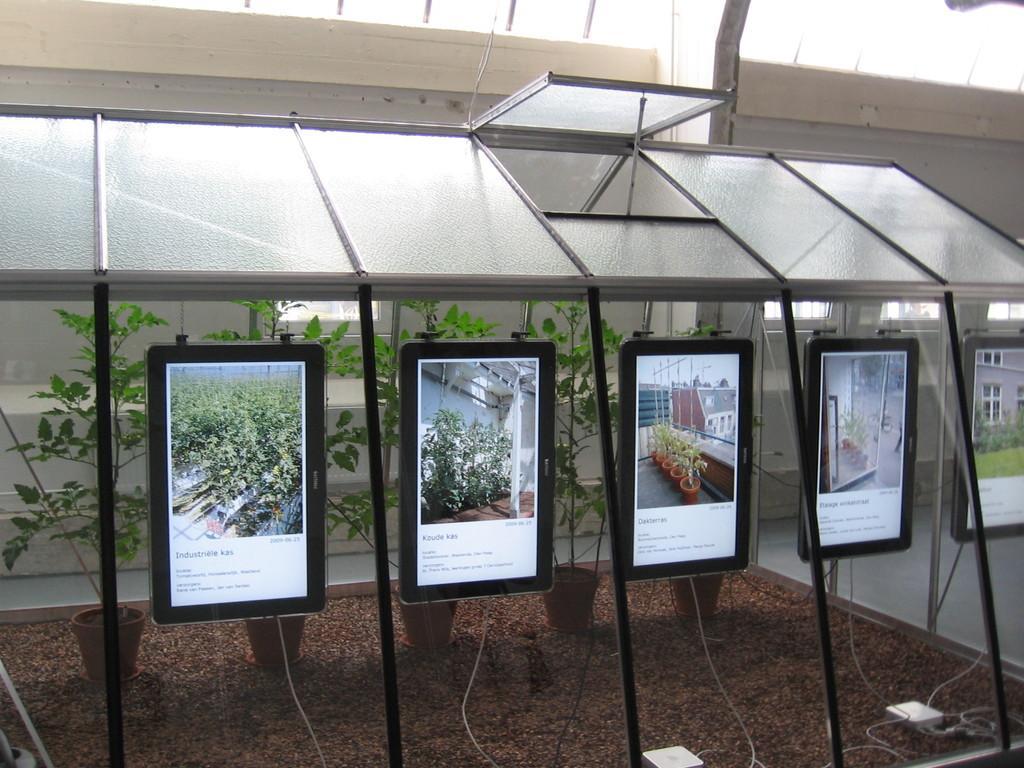Could you give a brief overview of what you see in this image? In this image we can see tablets. At the top there is a shed and we can see houseplants. At the bottom there are wires. In the background there is a building and grass. 